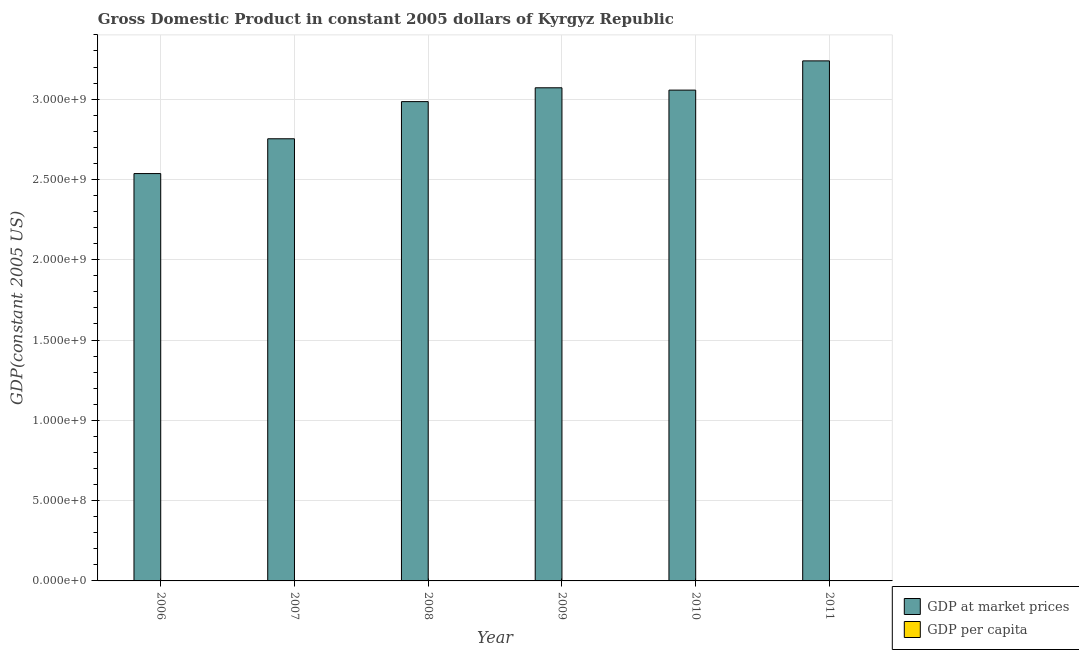Are the number of bars on each tick of the X-axis equal?
Provide a short and direct response. Yes. How many bars are there on the 1st tick from the left?
Make the answer very short. 2. How many bars are there on the 6th tick from the right?
Offer a terse response. 2. What is the label of the 4th group of bars from the left?
Keep it short and to the point. 2009. In how many cases, is the number of bars for a given year not equal to the number of legend labels?
Keep it short and to the point. 0. What is the gdp per capita in 2007?
Provide a short and direct response. 522.6. Across all years, what is the maximum gdp at market prices?
Provide a succinct answer. 3.24e+09. Across all years, what is the minimum gdp per capita?
Give a very brief answer. 486.08. In which year was the gdp at market prices maximum?
Make the answer very short. 2011. What is the total gdp at market prices in the graph?
Ensure brevity in your answer.  1.76e+1. What is the difference between the gdp at market prices in 2007 and that in 2009?
Your response must be concise. -3.17e+08. What is the difference between the gdp at market prices in 2006 and the gdp per capita in 2007?
Your answer should be very brief. -2.17e+08. What is the average gdp at market prices per year?
Provide a succinct answer. 2.94e+09. In how many years, is the gdp at market prices greater than 400000000 US$?
Your response must be concise. 6. What is the ratio of the gdp per capita in 2007 to that in 2008?
Your answer should be very brief. 0.93. What is the difference between the highest and the second highest gdp per capita?
Ensure brevity in your answer.  16.8. What is the difference between the highest and the lowest gdp per capita?
Your answer should be very brief. 101.14. In how many years, is the gdp at market prices greater than the average gdp at market prices taken over all years?
Your response must be concise. 4. What does the 2nd bar from the left in 2008 represents?
Provide a short and direct response. GDP per capita. What does the 2nd bar from the right in 2010 represents?
Give a very brief answer. GDP at market prices. How many years are there in the graph?
Your answer should be very brief. 6. What is the difference between two consecutive major ticks on the Y-axis?
Provide a succinct answer. 5.00e+08. Are the values on the major ticks of Y-axis written in scientific E-notation?
Your answer should be compact. Yes. How many legend labels are there?
Offer a very short reply. 2. What is the title of the graph?
Offer a very short reply. Gross Domestic Product in constant 2005 dollars of Kyrgyz Republic. What is the label or title of the X-axis?
Provide a succinct answer. Year. What is the label or title of the Y-axis?
Provide a short and direct response. GDP(constant 2005 US). What is the GDP(constant 2005 US) of GDP at market prices in 2006?
Make the answer very short. 2.54e+09. What is the GDP(constant 2005 US) in GDP per capita in 2006?
Your answer should be very brief. 486.08. What is the GDP(constant 2005 US) in GDP at market prices in 2007?
Your answer should be compact. 2.75e+09. What is the GDP(constant 2005 US) in GDP per capita in 2007?
Provide a succinct answer. 522.6. What is the GDP(constant 2005 US) in GDP at market prices in 2008?
Offer a terse response. 2.98e+09. What is the GDP(constant 2005 US) of GDP per capita in 2008?
Offer a terse response. 561.15. What is the GDP(constant 2005 US) of GDP at market prices in 2009?
Ensure brevity in your answer.  3.07e+09. What is the GDP(constant 2005 US) of GDP per capita in 2009?
Keep it short and to the point. 570.42. What is the GDP(constant 2005 US) in GDP at market prices in 2010?
Offer a very short reply. 3.06e+09. What is the GDP(constant 2005 US) in GDP per capita in 2010?
Make the answer very short. 561. What is the GDP(constant 2005 US) of GDP at market prices in 2011?
Provide a succinct answer. 3.24e+09. What is the GDP(constant 2005 US) in GDP per capita in 2011?
Keep it short and to the point. 587.22. Across all years, what is the maximum GDP(constant 2005 US) of GDP at market prices?
Keep it short and to the point. 3.24e+09. Across all years, what is the maximum GDP(constant 2005 US) in GDP per capita?
Offer a very short reply. 587.22. Across all years, what is the minimum GDP(constant 2005 US) in GDP at market prices?
Give a very brief answer. 2.54e+09. Across all years, what is the minimum GDP(constant 2005 US) in GDP per capita?
Provide a short and direct response. 486.08. What is the total GDP(constant 2005 US) of GDP at market prices in the graph?
Offer a terse response. 1.76e+1. What is the total GDP(constant 2005 US) of GDP per capita in the graph?
Ensure brevity in your answer.  3288.49. What is the difference between the GDP(constant 2005 US) in GDP at market prices in 2006 and that in 2007?
Offer a terse response. -2.17e+08. What is the difference between the GDP(constant 2005 US) in GDP per capita in 2006 and that in 2007?
Offer a very short reply. -36.52. What is the difference between the GDP(constant 2005 US) of GDP at market prices in 2006 and that in 2008?
Make the answer very short. -4.48e+08. What is the difference between the GDP(constant 2005 US) in GDP per capita in 2006 and that in 2008?
Give a very brief answer. -75.07. What is the difference between the GDP(constant 2005 US) of GDP at market prices in 2006 and that in 2009?
Keep it short and to the point. -5.34e+08. What is the difference between the GDP(constant 2005 US) in GDP per capita in 2006 and that in 2009?
Ensure brevity in your answer.  -84.34. What is the difference between the GDP(constant 2005 US) in GDP at market prices in 2006 and that in 2010?
Give a very brief answer. -5.20e+08. What is the difference between the GDP(constant 2005 US) in GDP per capita in 2006 and that in 2010?
Your response must be concise. -74.91. What is the difference between the GDP(constant 2005 US) in GDP at market prices in 2006 and that in 2011?
Your answer should be compact. -7.02e+08. What is the difference between the GDP(constant 2005 US) of GDP per capita in 2006 and that in 2011?
Ensure brevity in your answer.  -101.14. What is the difference between the GDP(constant 2005 US) of GDP at market prices in 2007 and that in 2008?
Give a very brief answer. -2.31e+08. What is the difference between the GDP(constant 2005 US) of GDP per capita in 2007 and that in 2008?
Offer a terse response. -38.55. What is the difference between the GDP(constant 2005 US) of GDP at market prices in 2007 and that in 2009?
Make the answer very short. -3.17e+08. What is the difference between the GDP(constant 2005 US) in GDP per capita in 2007 and that in 2009?
Provide a succinct answer. -47.82. What is the difference between the GDP(constant 2005 US) in GDP at market prices in 2007 and that in 2010?
Make the answer very short. -3.03e+08. What is the difference between the GDP(constant 2005 US) of GDP per capita in 2007 and that in 2010?
Provide a short and direct response. -38.4. What is the difference between the GDP(constant 2005 US) of GDP at market prices in 2007 and that in 2011?
Keep it short and to the point. -4.85e+08. What is the difference between the GDP(constant 2005 US) of GDP per capita in 2007 and that in 2011?
Provide a short and direct response. -64.62. What is the difference between the GDP(constant 2005 US) in GDP at market prices in 2008 and that in 2009?
Provide a short and direct response. -8.61e+07. What is the difference between the GDP(constant 2005 US) in GDP per capita in 2008 and that in 2009?
Provide a succinct answer. -9.27. What is the difference between the GDP(constant 2005 US) in GDP at market prices in 2008 and that in 2010?
Your answer should be very brief. -7.17e+07. What is the difference between the GDP(constant 2005 US) of GDP per capita in 2008 and that in 2010?
Keep it short and to the point. 0.15. What is the difference between the GDP(constant 2005 US) of GDP at market prices in 2008 and that in 2011?
Offer a very short reply. -2.54e+08. What is the difference between the GDP(constant 2005 US) of GDP per capita in 2008 and that in 2011?
Keep it short and to the point. -26.07. What is the difference between the GDP(constant 2005 US) in GDP at market prices in 2009 and that in 2010?
Make the answer very short. 1.45e+07. What is the difference between the GDP(constant 2005 US) in GDP per capita in 2009 and that in 2010?
Provide a succinct answer. 9.42. What is the difference between the GDP(constant 2005 US) in GDP at market prices in 2009 and that in 2011?
Give a very brief answer. -1.68e+08. What is the difference between the GDP(constant 2005 US) of GDP per capita in 2009 and that in 2011?
Give a very brief answer. -16.8. What is the difference between the GDP(constant 2005 US) in GDP at market prices in 2010 and that in 2011?
Give a very brief answer. -1.82e+08. What is the difference between the GDP(constant 2005 US) of GDP per capita in 2010 and that in 2011?
Make the answer very short. -26.23. What is the difference between the GDP(constant 2005 US) in GDP at market prices in 2006 and the GDP(constant 2005 US) in GDP per capita in 2007?
Ensure brevity in your answer.  2.54e+09. What is the difference between the GDP(constant 2005 US) of GDP at market prices in 2006 and the GDP(constant 2005 US) of GDP per capita in 2008?
Your answer should be compact. 2.54e+09. What is the difference between the GDP(constant 2005 US) of GDP at market prices in 2006 and the GDP(constant 2005 US) of GDP per capita in 2009?
Your answer should be very brief. 2.54e+09. What is the difference between the GDP(constant 2005 US) of GDP at market prices in 2006 and the GDP(constant 2005 US) of GDP per capita in 2010?
Your answer should be very brief. 2.54e+09. What is the difference between the GDP(constant 2005 US) in GDP at market prices in 2006 and the GDP(constant 2005 US) in GDP per capita in 2011?
Give a very brief answer. 2.54e+09. What is the difference between the GDP(constant 2005 US) in GDP at market prices in 2007 and the GDP(constant 2005 US) in GDP per capita in 2008?
Make the answer very short. 2.75e+09. What is the difference between the GDP(constant 2005 US) in GDP at market prices in 2007 and the GDP(constant 2005 US) in GDP per capita in 2009?
Keep it short and to the point. 2.75e+09. What is the difference between the GDP(constant 2005 US) of GDP at market prices in 2007 and the GDP(constant 2005 US) of GDP per capita in 2010?
Make the answer very short. 2.75e+09. What is the difference between the GDP(constant 2005 US) in GDP at market prices in 2007 and the GDP(constant 2005 US) in GDP per capita in 2011?
Provide a short and direct response. 2.75e+09. What is the difference between the GDP(constant 2005 US) in GDP at market prices in 2008 and the GDP(constant 2005 US) in GDP per capita in 2009?
Offer a terse response. 2.98e+09. What is the difference between the GDP(constant 2005 US) of GDP at market prices in 2008 and the GDP(constant 2005 US) of GDP per capita in 2010?
Ensure brevity in your answer.  2.98e+09. What is the difference between the GDP(constant 2005 US) of GDP at market prices in 2008 and the GDP(constant 2005 US) of GDP per capita in 2011?
Provide a short and direct response. 2.98e+09. What is the difference between the GDP(constant 2005 US) of GDP at market prices in 2009 and the GDP(constant 2005 US) of GDP per capita in 2010?
Make the answer very short. 3.07e+09. What is the difference between the GDP(constant 2005 US) in GDP at market prices in 2009 and the GDP(constant 2005 US) in GDP per capita in 2011?
Your answer should be very brief. 3.07e+09. What is the difference between the GDP(constant 2005 US) of GDP at market prices in 2010 and the GDP(constant 2005 US) of GDP per capita in 2011?
Keep it short and to the point. 3.06e+09. What is the average GDP(constant 2005 US) of GDP at market prices per year?
Give a very brief answer. 2.94e+09. What is the average GDP(constant 2005 US) of GDP per capita per year?
Offer a very short reply. 548.08. In the year 2006, what is the difference between the GDP(constant 2005 US) in GDP at market prices and GDP(constant 2005 US) in GDP per capita?
Provide a short and direct response. 2.54e+09. In the year 2007, what is the difference between the GDP(constant 2005 US) in GDP at market prices and GDP(constant 2005 US) in GDP per capita?
Offer a terse response. 2.75e+09. In the year 2008, what is the difference between the GDP(constant 2005 US) in GDP at market prices and GDP(constant 2005 US) in GDP per capita?
Provide a short and direct response. 2.98e+09. In the year 2009, what is the difference between the GDP(constant 2005 US) of GDP at market prices and GDP(constant 2005 US) of GDP per capita?
Keep it short and to the point. 3.07e+09. In the year 2010, what is the difference between the GDP(constant 2005 US) in GDP at market prices and GDP(constant 2005 US) in GDP per capita?
Provide a succinct answer. 3.06e+09. In the year 2011, what is the difference between the GDP(constant 2005 US) in GDP at market prices and GDP(constant 2005 US) in GDP per capita?
Keep it short and to the point. 3.24e+09. What is the ratio of the GDP(constant 2005 US) in GDP at market prices in 2006 to that in 2007?
Your answer should be very brief. 0.92. What is the ratio of the GDP(constant 2005 US) in GDP per capita in 2006 to that in 2007?
Keep it short and to the point. 0.93. What is the ratio of the GDP(constant 2005 US) of GDP at market prices in 2006 to that in 2008?
Ensure brevity in your answer.  0.85. What is the ratio of the GDP(constant 2005 US) in GDP per capita in 2006 to that in 2008?
Offer a terse response. 0.87. What is the ratio of the GDP(constant 2005 US) in GDP at market prices in 2006 to that in 2009?
Your answer should be compact. 0.83. What is the ratio of the GDP(constant 2005 US) of GDP per capita in 2006 to that in 2009?
Your answer should be compact. 0.85. What is the ratio of the GDP(constant 2005 US) of GDP at market prices in 2006 to that in 2010?
Give a very brief answer. 0.83. What is the ratio of the GDP(constant 2005 US) of GDP per capita in 2006 to that in 2010?
Your response must be concise. 0.87. What is the ratio of the GDP(constant 2005 US) in GDP at market prices in 2006 to that in 2011?
Provide a succinct answer. 0.78. What is the ratio of the GDP(constant 2005 US) in GDP per capita in 2006 to that in 2011?
Ensure brevity in your answer.  0.83. What is the ratio of the GDP(constant 2005 US) of GDP at market prices in 2007 to that in 2008?
Offer a very short reply. 0.92. What is the ratio of the GDP(constant 2005 US) in GDP per capita in 2007 to that in 2008?
Keep it short and to the point. 0.93. What is the ratio of the GDP(constant 2005 US) of GDP at market prices in 2007 to that in 2009?
Your answer should be compact. 0.9. What is the ratio of the GDP(constant 2005 US) in GDP per capita in 2007 to that in 2009?
Your response must be concise. 0.92. What is the ratio of the GDP(constant 2005 US) of GDP at market prices in 2007 to that in 2010?
Make the answer very short. 0.9. What is the ratio of the GDP(constant 2005 US) in GDP per capita in 2007 to that in 2010?
Make the answer very short. 0.93. What is the ratio of the GDP(constant 2005 US) of GDP at market prices in 2007 to that in 2011?
Offer a very short reply. 0.85. What is the ratio of the GDP(constant 2005 US) of GDP per capita in 2007 to that in 2011?
Ensure brevity in your answer.  0.89. What is the ratio of the GDP(constant 2005 US) of GDP at market prices in 2008 to that in 2009?
Provide a short and direct response. 0.97. What is the ratio of the GDP(constant 2005 US) in GDP per capita in 2008 to that in 2009?
Offer a very short reply. 0.98. What is the ratio of the GDP(constant 2005 US) in GDP at market prices in 2008 to that in 2010?
Provide a succinct answer. 0.98. What is the ratio of the GDP(constant 2005 US) in GDP per capita in 2008 to that in 2010?
Offer a terse response. 1. What is the ratio of the GDP(constant 2005 US) in GDP at market prices in 2008 to that in 2011?
Offer a terse response. 0.92. What is the ratio of the GDP(constant 2005 US) of GDP per capita in 2008 to that in 2011?
Offer a very short reply. 0.96. What is the ratio of the GDP(constant 2005 US) of GDP at market prices in 2009 to that in 2010?
Your answer should be very brief. 1. What is the ratio of the GDP(constant 2005 US) in GDP per capita in 2009 to that in 2010?
Your answer should be very brief. 1.02. What is the ratio of the GDP(constant 2005 US) of GDP at market prices in 2009 to that in 2011?
Give a very brief answer. 0.95. What is the ratio of the GDP(constant 2005 US) of GDP per capita in 2009 to that in 2011?
Give a very brief answer. 0.97. What is the ratio of the GDP(constant 2005 US) in GDP at market prices in 2010 to that in 2011?
Ensure brevity in your answer.  0.94. What is the ratio of the GDP(constant 2005 US) in GDP per capita in 2010 to that in 2011?
Give a very brief answer. 0.96. What is the difference between the highest and the second highest GDP(constant 2005 US) of GDP at market prices?
Provide a succinct answer. 1.68e+08. What is the difference between the highest and the second highest GDP(constant 2005 US) in GDP per capita?
Provide a succinct answer. 16.8. What is the difference between the highest and the lowest GDP(constant 2005 US) of GDP at market prices?
Your answer should be very brief. 7.02e+08. What is the difference between the highest and the lowest GDP(constant 2005 US) in GDP per capita?
Keep it short and to the point. 101.14. 